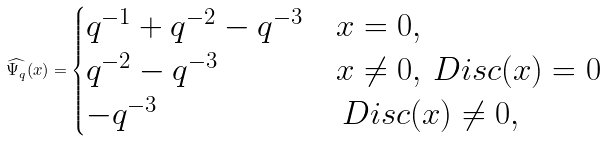<formula> <loc_0><loc_0><loc_500><loc_500>\widehat { \Psi _ { q } } ( x ) = \begin{cases} q ^ { - 1 } + q ^ { - 2 } - q ^ { - 3 } & x = 0 , \\ q ^ { - 2 } - q ^ { - 3 } & x \neq 0 , \ D i s c ( x ) = 0 \\ - q ^ { - 3 } & \ D i s c ( x ) \neq 0 , \\ \end{cases}</formula> 